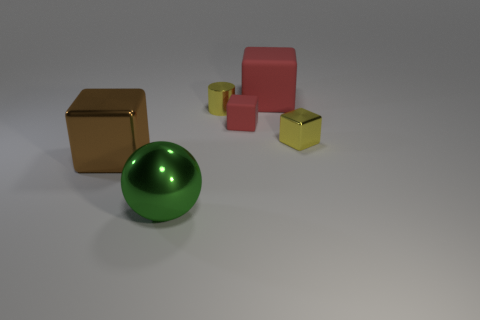Subtract all cyan cylinders. Subtract all blue balls. How many cylinders are left? 1 Add 3 big red metallic cylinders. How many objects exist? 9 Subtract all spheres. How many objects are left? 5 Subtract 1 yellow cylinders. How many objects are left? 5 Subtract all small yellow shiny cubes. Subtract all tiny red rubber objects. How many objects are left? 4 Add 4 metal blocks. How many metal blocks are left? 6 Add 4 matte things. How many matte things exist? 6 